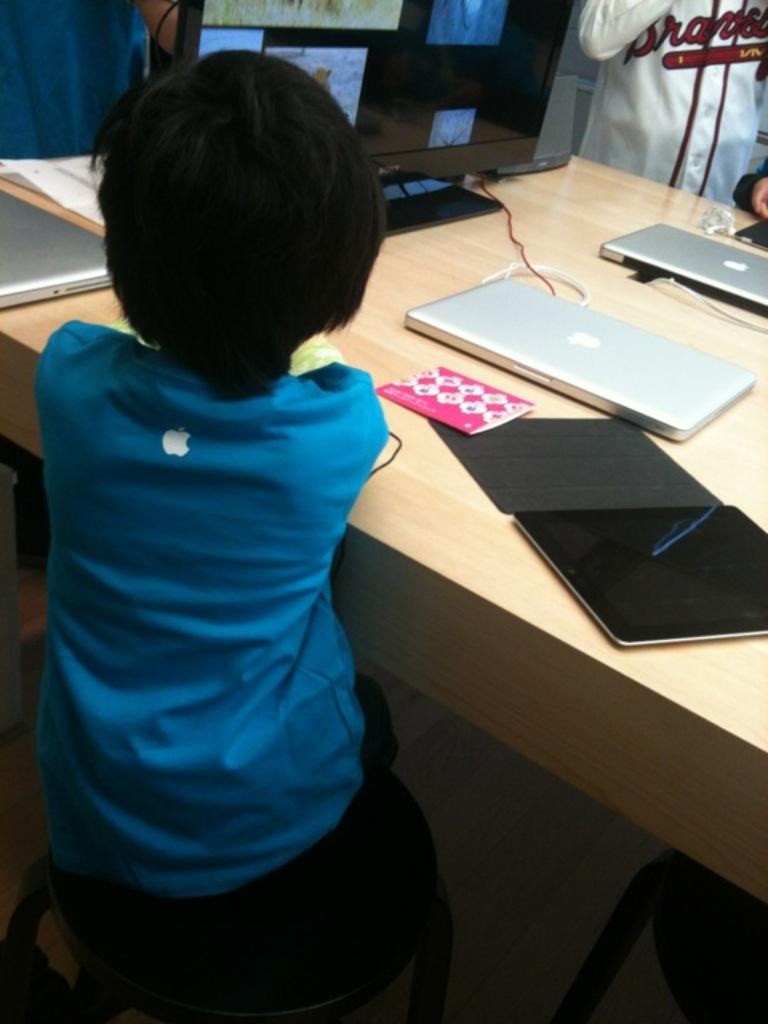What is the main subject of the image? The main subject of the image is a kid. What is the kid wearing? The kid is wearing a blue t-shirt. What is the kid's position in the image? The kid is sitting on a chair. What is the chair's location in relation to the table? The chair is beside a table. What items can be seen on the table? There is a book, two laptops, a system, and some papers on the table. What is the kid's reaction to the fear of flying at the airport in the image? There is no mention of fear, flying, or an airport in the image. The image only shows a kid sitting on a chair beside a table with various items on it. 